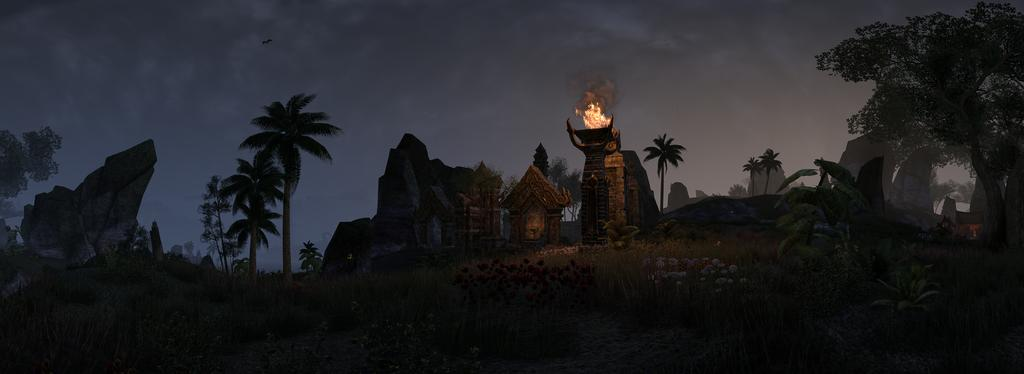What type of natural elements can be seen in the image? There are rocks, trees, flowers, and plants visible in the image. What is the source of fire in the image? There is fire on a pillar in the image. What type of artwork is present in the image? There are sculptures in the image. What part of the natural environment is visible in the image? The sky is visible in the image. What type of haircut is the tent getting in the image? There is no tent or haircut present in the image. What color is the sky in the image? The provided facts do not mention the color of the sky, so we cannot definitively answer that question. 